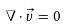Convert formula to latex. <formula><loc_0><loc_0><loc_500><loc_500>\nabla \cdot \vec { v } = 0</formula> 